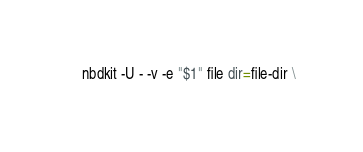<code> <loc_0><loc_0><loc_500><loc_500><_Bash_>    nbdkit -U - -v -e "$1" file dir=file-dir \</code> 